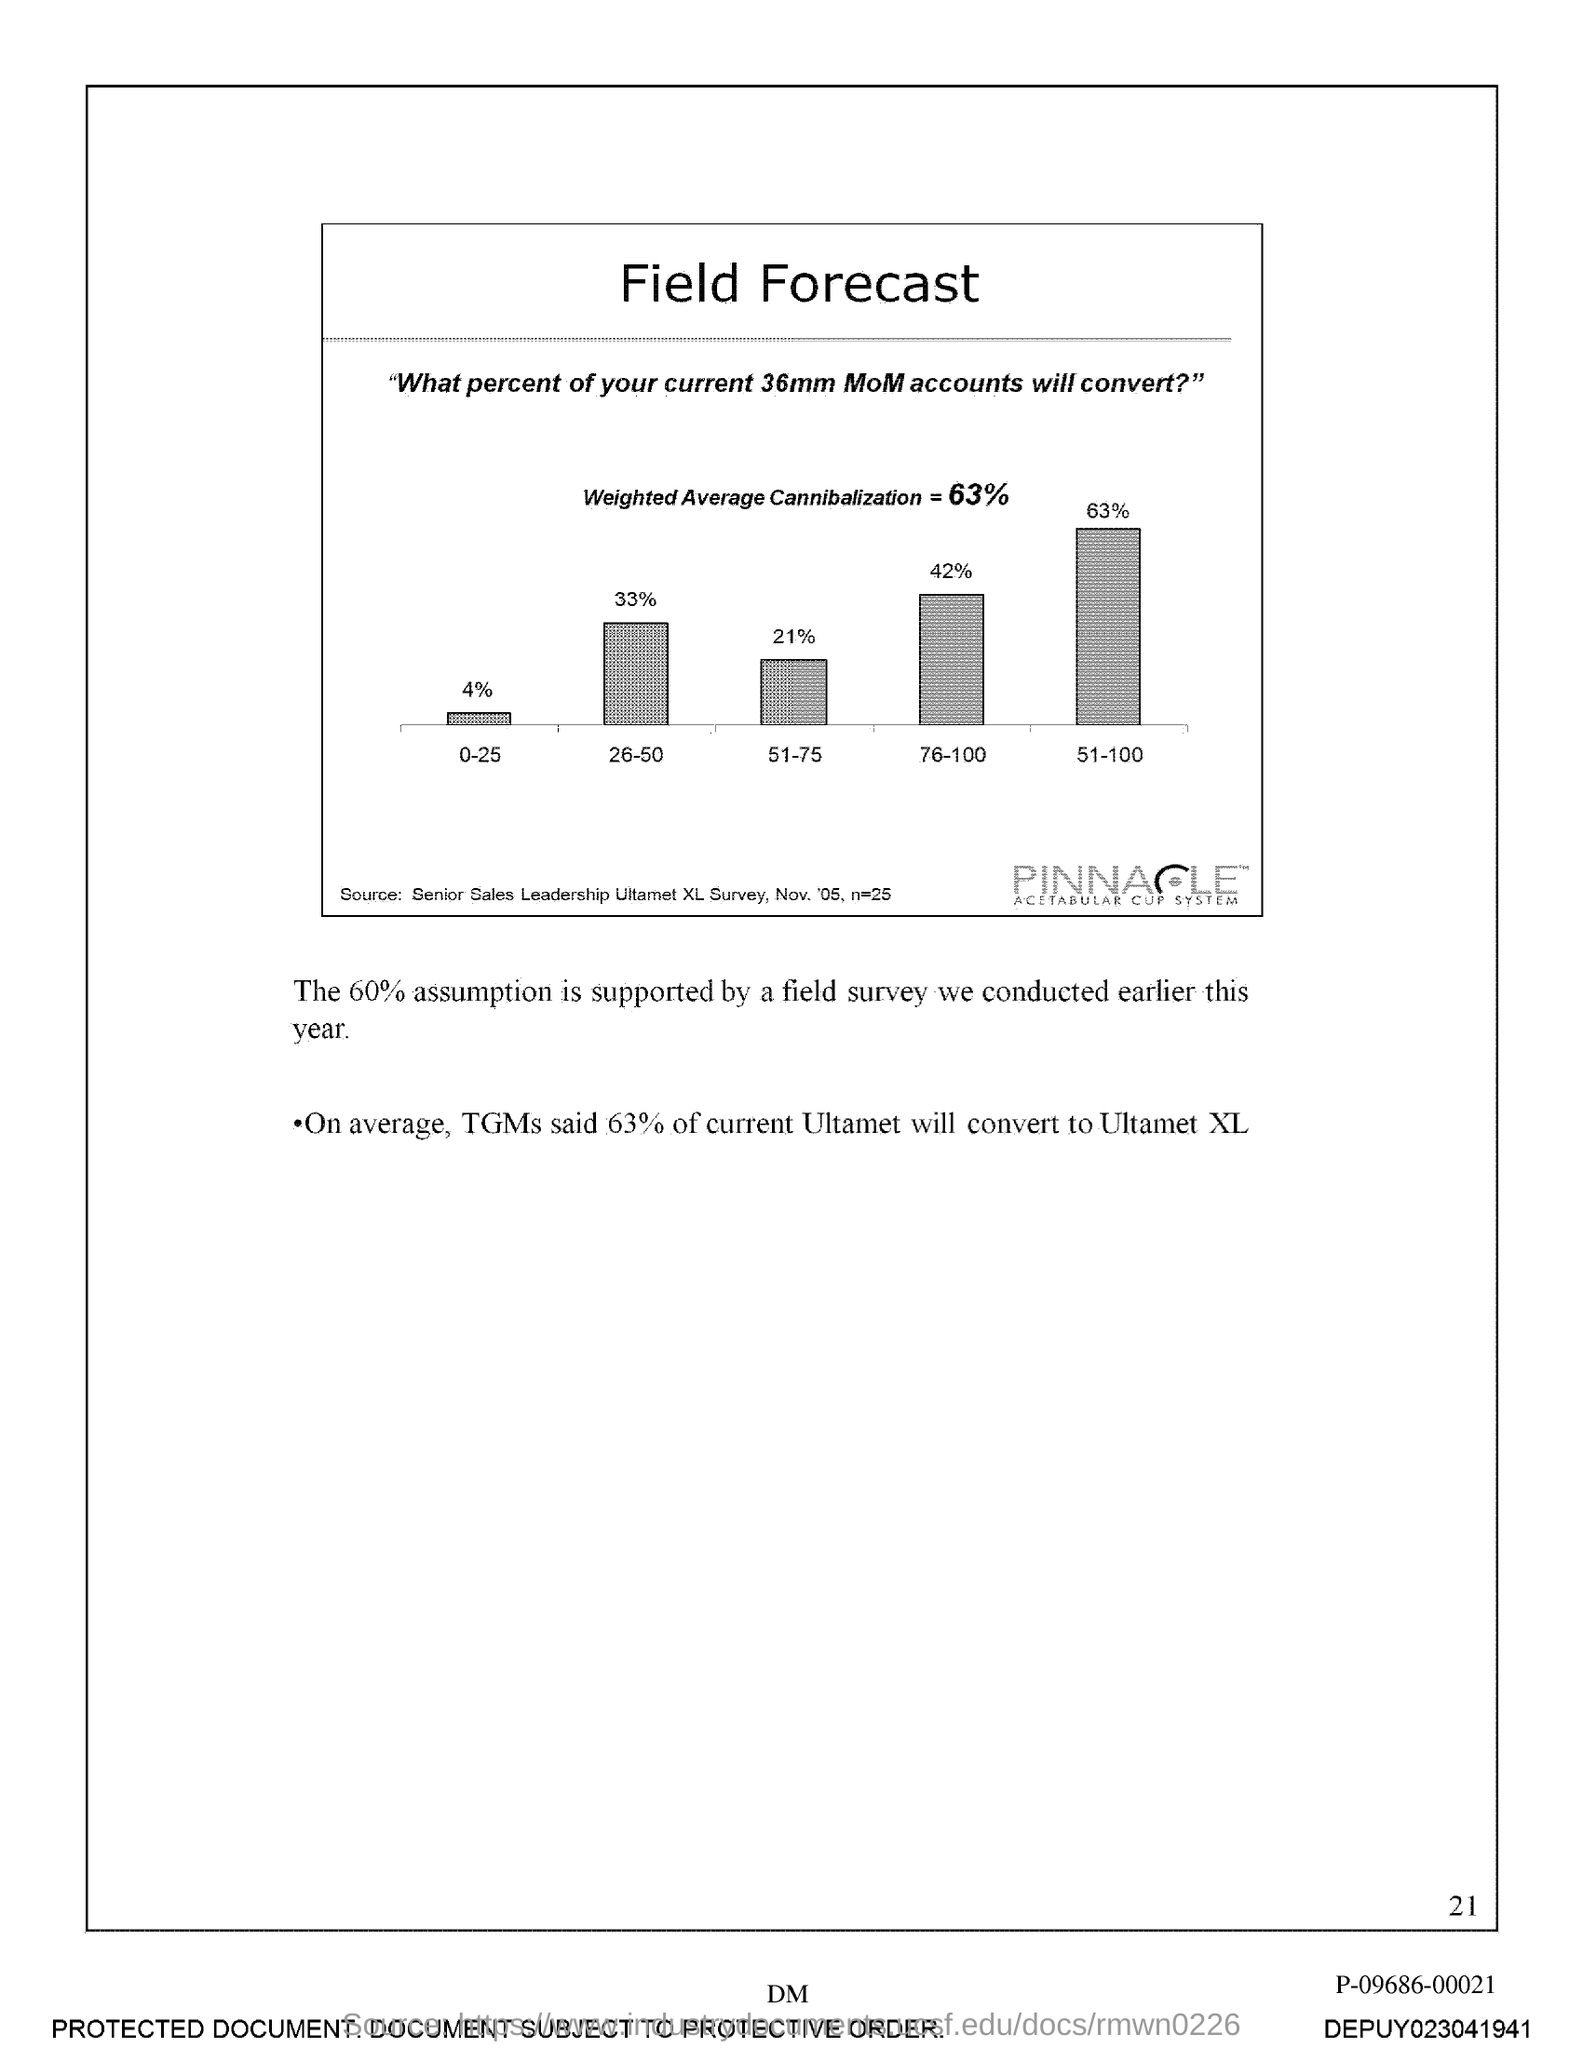Indicate a few pertinent items in this graphic. The weighted average cannibalization is 63%. On average, 63% of current Ultamet will convert to Ultamet XL. The title of the graph is 'Field Forecast.' The field survey supports 60% of the assumption. 